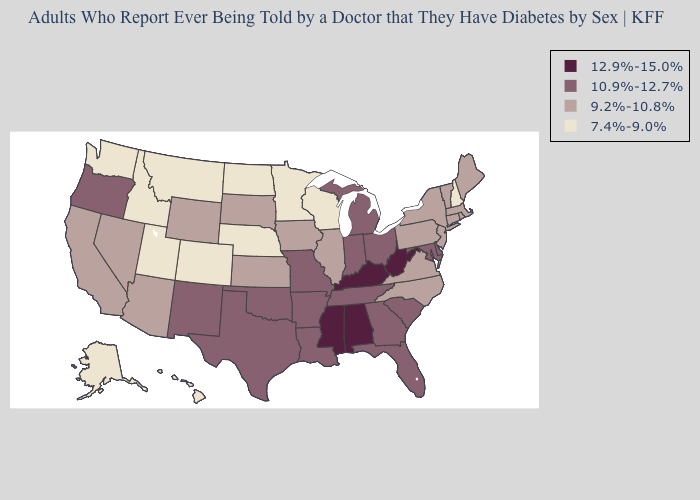Name the states that have a value in the range 10.9%-12.7%?
Write a very short answer. Arkansas, Delaware, Florida, Georgia, Indiana, Louisiana, Maryland, Michigan, Missouri, New Mexico, Ohio, Oklahoma, Oregon, South Carolina, Tennessee, Texas. What is the lowest value in states that border New York?
Short answer required. 9.2%-10.8%. What is the value of Alabama?
Concise answer only. 12.9%-15.0%. Name the states that have a value in the range 12.9%-15.0%?
Write a very short answer. Alabama, Kentucky, Mississippi, West Virginia. What is the value of New Mexico?
Write a very short answer. 10.9%-12.7%. Name the states that have a value in the range 12.9%-15.0%?
Keep it brief. Alabama, Kentucky, Mississippi, West Virginia. What is the value of South Dakota?
Short answer required. 9.2%-10.8%. Does Vermont have the same value as Illinois?
Answer briefly. Yes. How many symbols are there in the legend?
Give a very brief answer. 4. Among the states that border New York , which have the lowest value?
Answer briefly. Connecticut, Massachusetts, New Jersey, Pennsylvania, Vermont. Which states have the lowest value in the USA?
Give a very brief answer. Alaska, Colorado, Hawaii, Idaho, Minnesota, Montana, Nebraska, New Hampshire, North Dakota, Utah, Washington, Wisconsin. Which states have the lowest value in the South?
Quick response, please. North Carolina, Virginia. Among the states that border Ohio , does Kentucky have the lowest value?
Keep it brief. No. Does Delaware have a higher value than New Mexico?
Give a very brief answer. No. Name the states that have a value in the range 7.4%-9.0%?
Short answer required. Alaska, Colorado, Hawaii, Idaho, Minnesota, Montana, Nebraska, New Hampshire, North Dakota, Utah, Washington, Wisconsin. 